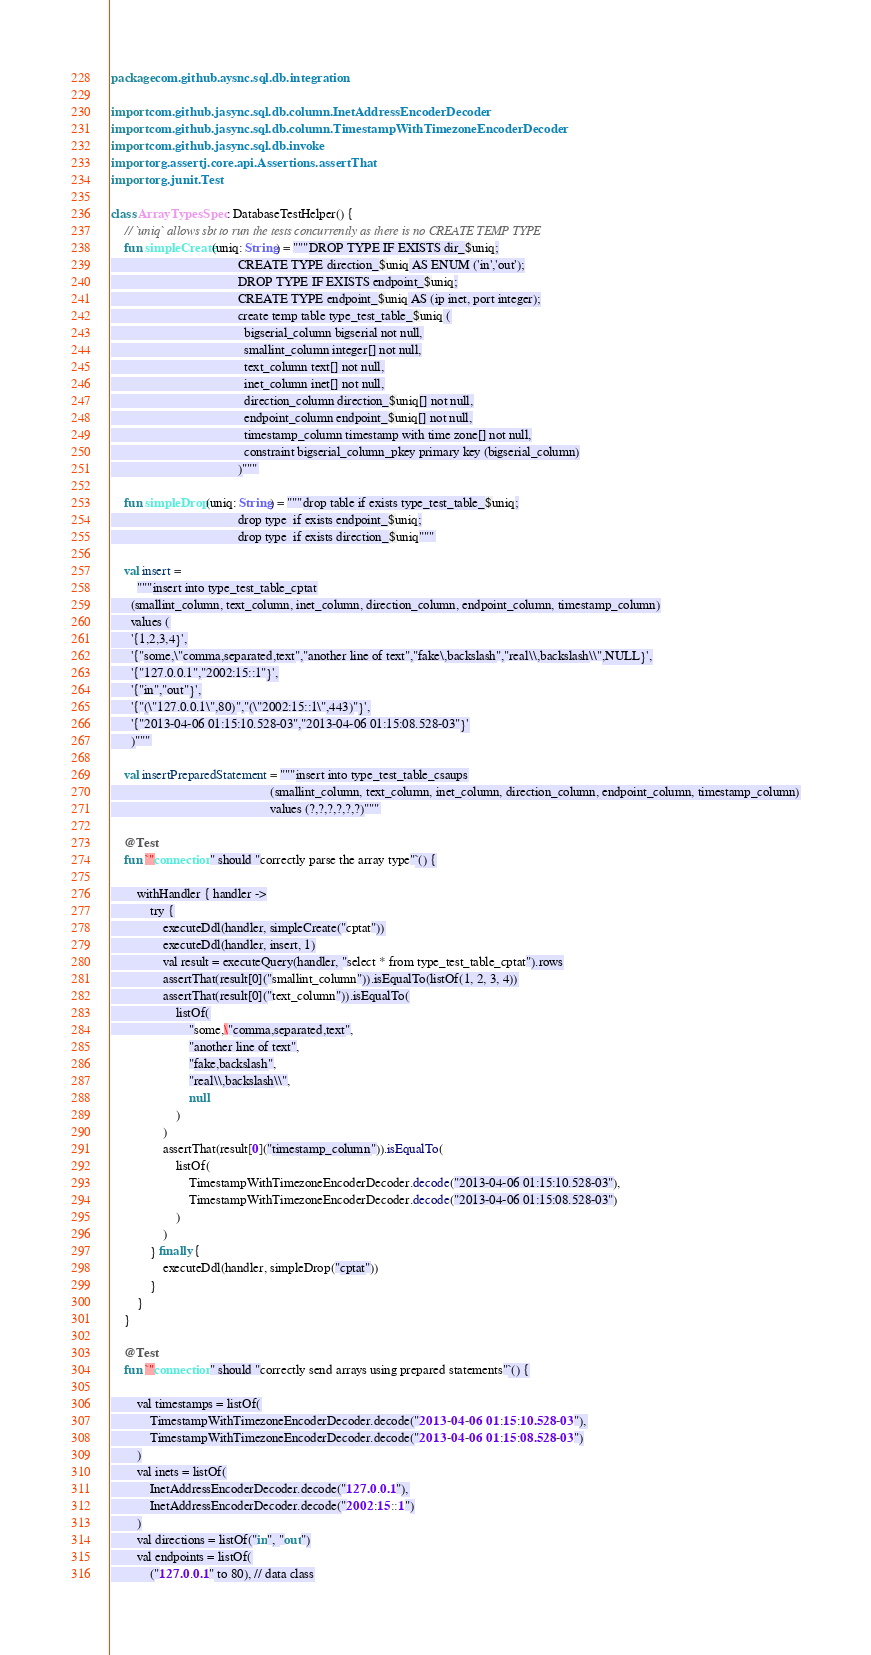<code> <loc_0><loc_0><loc_500><loc_500><_Kotlin_>package com.github.aysnc.sql.db.integration

import com.github.jasync.sql.db.column.InetAddressEncoderDecoder
import com.github.jasync.sql.db.column.TimestampWithTimezoneEncoderDecoder
import com.github.jasync.sql.db.invoke
import org.assertj.core.api.Assertions.assertThat
import org.junit.Test

class ArrayTypesSpec : DatabaseTestHelper() {
    // `uniq` allows sbt to run the tests concurrently as there is no CREATE TEMP TYPE
    fun simpleCreate(uniq: String) = """DROP TYPE IF EXISTS dir_$uniq;
                                       CREATE TYPE direction_$uniq AS ENUM ('in','out');
                                       DROP TYPE IF EXISTS endpoint_$uniq;
                                       CREATE TYPE endpoint_$uniq AS (ip inet, port integer);
                                       create temp table type_test_table_$uniq (
                                         bigserial_column bigserial not null,
                                         smallint_column integer[] not null,
                                         text_column text[] not null,
                                         inet_column inet[] not null,
                                         direction_column direction_$uniq[] not null,
                                         endpoint_column endpoint_$uniq[] not null,
                                         timestamp_column timestamp with time zone[] not null,
                                         constraint bigserial_column_pkey primary key (bigserial_column)
                                       )"""

    fun simpleDrop(uniq: String) = """drop table if exists type_test_table_$uniq;
                                       drop type  if exists endpoint_$uniq;
                                       drop type  if exists direction_$uniq"""

    val insert =
        """insert into type_test_table_cptat
      (smallint_column, text_column, inet_column, direction_column, endpoint_column, timestamp_column)
      values (
      '{1,2,3,4}',
      '{"some,\"comma,separated,text","another line of text","fake\,backslash","real\\,backslash\\",NULL}',
      '{"127.0.0.1","2002:15::1"}',
      '{"in","out"}',
      '{"(\"127.0.0.1\",80)","(\"2002:15::1\",443)"}',
      '{"2013-04-06 01:15:10.528-03","2013-04-06 01:15:08.528-03"}'
      )"""

    val insertPreparedStatement = """insert into type_test_table_csaups
                                                 (smallint_column, text_column, inet_column, direction_column, endpoint_column, timestamp_column)
                                                 values (?,?,?,?,?,?)"""

    @Test
    fun `"connection" should "correctly parse the array type"`() {

        withHandler { handler ->
            try {
                executeDdl(handler, simpleCreate("cptat"))
                executeDdl(handler, insert, 1)
                val result = executeQuery(handler, "select * from type_test_table_cptat").rows
                assertThat(result[0]("smallint_column")).isEqualTo(listOf(1, 2, 3, 4))
                assertThat(result[0]("text_column")).isEqualTo(
                    listOf(
                        "some,\"comma,separated,text",
                        "another line of text",
                        "fake,backslash",
                        "real\\,backslash\\",
                        null
                    )
                )
                assertThat(result[0]("timestamp_column")).isEqualTo(
                    listOf(
                        TimestampWithTimezoneEncoderDecoder.decode("2013-04-06 01:15:10.528-03"),
                        TimestampWithTimezoneEncoderDecoder.decode("2013-04-06 01:15:08.528-03")
                    )
                )
            } finally {
                executeDdl(handler, simpleDrop("cptat"))
            }
        }
    }

    @Test
    fun `"connection" should "correctly send arrays using prepared statements"`() {

        val timestamps = listOf(
            TimestampWithTimezoneEncoderDecoder.decode("2013-04-06 01:15:10.528-03"),
            TimestampWithTimezoneEncoderDecoder.decode("2013-04-06 01:15:08.528-03")
        )
        val inets = listOf(
            InetAddressEncoderDecoder.decode("127.0.0.1"),
            InetAddressEncoderDecoder.decode("2002:15::1")
        )
        val directions = listOf("in", "out")
        val endpoints = listOf(
            ("127.0.0.1" to 80), // data class</code> 